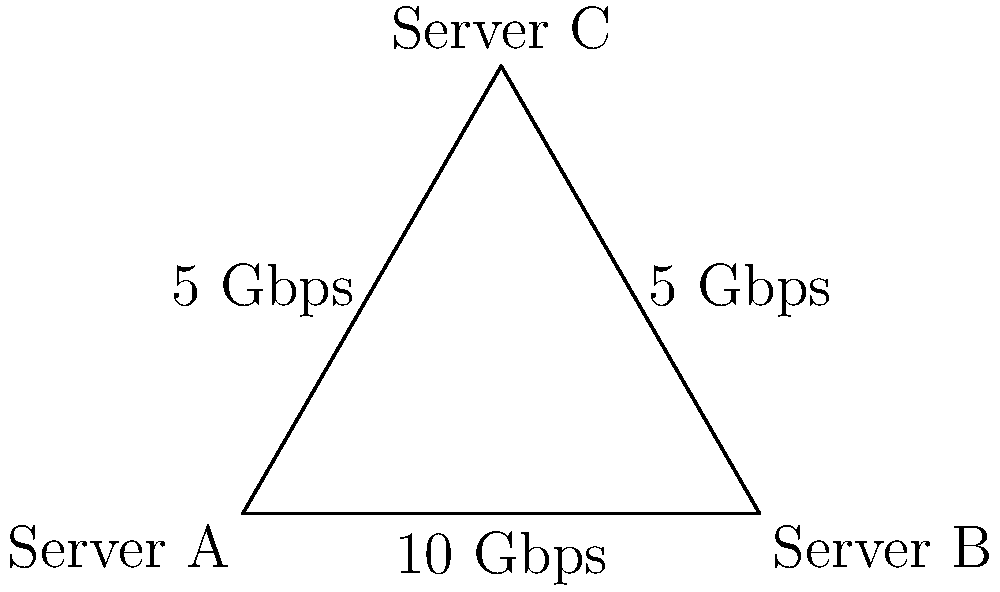In a Linux cluster, three servers (A, B, and C) are connected in a triangular topology as shown in the diagram. The connection between A and B has a bandwidth of 10 Gbps, while the connections from A to C and B to C both have 5 Gbps bandwidth. What is the maximum theoretical throughput for data transfer from Server A to Server C? To determine the maximum theoretical throughput from Server A to Server C, we need to consider all possible paths:

1. Direct path: A to C
   Throughput: 5 Gbps

2. Indirect path: A to B to C
   Step 1: A to B: 10 Gbps
   Step 2: B to C: 5 Gbps
   The throughput of this path is limited by the slowest link, which is 5 Gbps.

3. According to the max-flow min-cut theorem, the maximum flow between two nodes in a network is equal to the sum of the flows through all possible paths.

4. In this case, we have two paths, each with a throughput of 5 Gbps.

5. Therefore, the maximum theoretical throughput is:
   5 Gbps (direct path) + 5 Gbps (indirect path) = 10 Gbps

This assumes that the Linux system is configured to utilize both paths simultaneously, which can be achieved using techniques such as multipath TCP (MPTCP) or other load balancing mechanisms.
Answer: 10 Gbps 